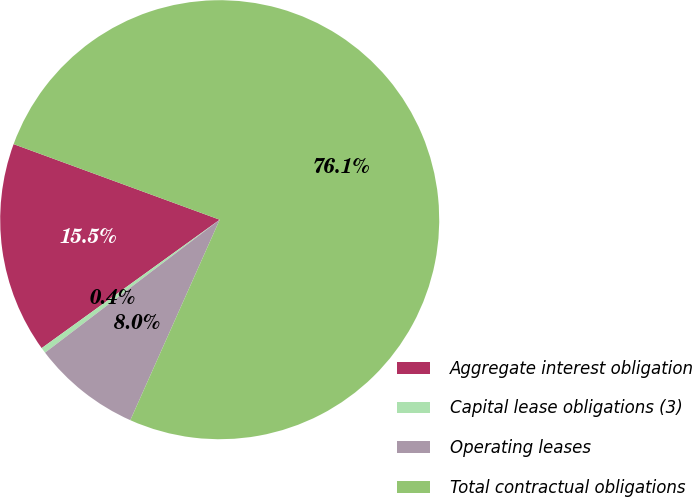<chart> <loc_0><loc_0><loc_500><loc_500><pie_chart><fcel>Aggregate interest obligation<fcel>Capital lease obligations (3)<fcel>Operating leases<fcel>Total contractual obligations<nl><fcel>15.54%<fcel>0.41%<fcel>7.97%<fcel>76.08%<nl></chart> 